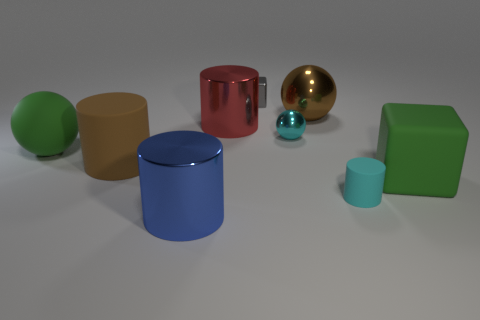Subtract all cylinders. How many objects are left? 5 Add 5 purple rubber objects. How many purple rubber objects exist? 5 Subtract 0 green cylinders. How many objects are left? 9 Subtract all small cyan rubber objects. Subtract all blue shiny things. How many objects are left? 7 Add 6 cylinders. How many cylinders are left? 10 